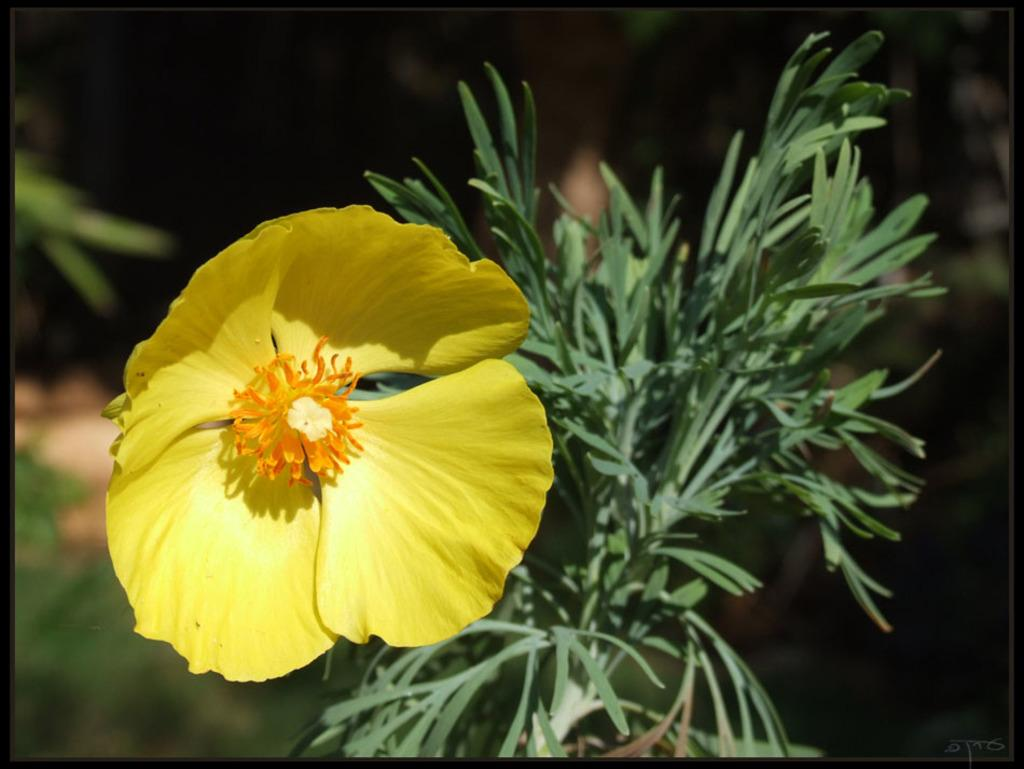What type of plant is visible in the image? There is a plant in the image, but the specific type cannot be determined from the provided facts. What is the most prominent feature of the plant? There is a flower in the image, which is the most prominent feature of the plant. What can be said about the background of the image? The background of the image is blurred. How would you describe the overall lighting in the image? The image is slightly dark. How many pages are visible in the image? There are no pages present in the image; it features a plant with a flower. What type of bead is used to decorate the hill in the image? There is no hill or bead present in the image; it features a plant with a flower. 